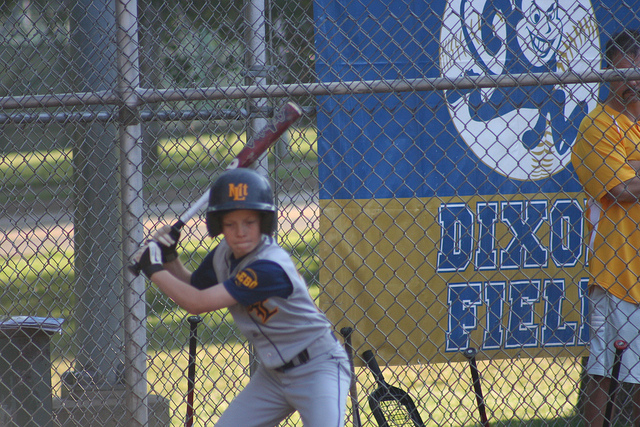<image>What brand is represented on the boy's clothing? It is unclear what brand is represented on the boy's clothing. What brand is represented on the boy's clothing? It is unknown what brand is represented on the boy's clothing. It is not visible in the image. 